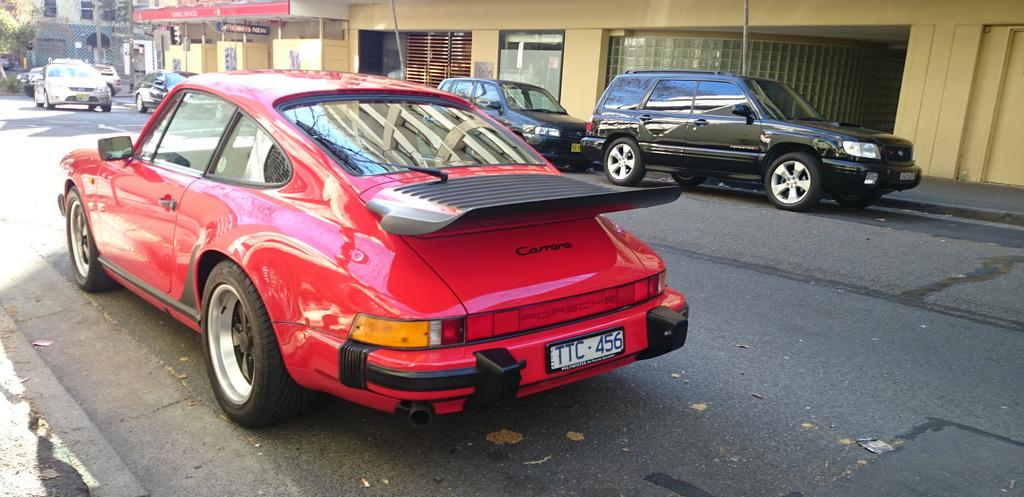What can be seen in the foreground of the image? There are cars in the foreground of the image. What is visible in the background of the image? There are buildings, posters, trees, and vehicles in the background of the image. Can you describe the types of structures in the background? The background features buildings and posters. What type of vegetation is present in the background? There are trees in the background of the image. What type of weather can be seen in the image? The provided facts do not mention any weather conditions, so it cannot be determined from the image. What type of paste is used to create the posters in the image? There is no information about the materials used to create the posters in the image. Is there an oven visible in the image? No, there is no oven present in the image. 